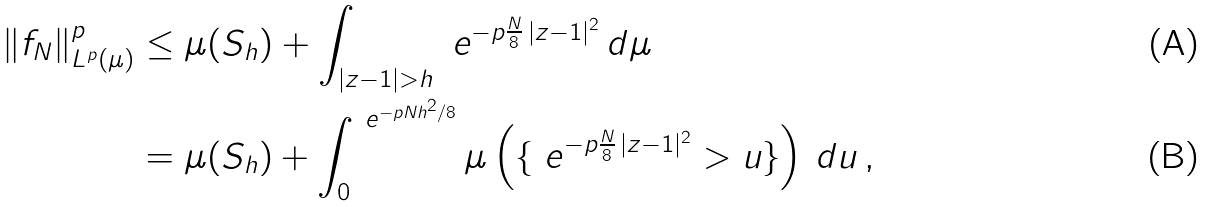Convert formula to latex. <formula><loc_0><loc_0><loc_500><loc_500>\| f _ { N } \| _ { L ^ { p } ( \mu ) } ^ { p } & \leq \mu ( S _ { h } ) + \int _ { | z - 1 | > h } \ e ^ { - p \frac { N } { 8 } \, | z - 1 | ^ { 2 } } \, d \mu \\ & = \mu ( S _ { h } ) + \int _ { 0 } ^ { \ e ^ { - p N h ^ { 2 } / 8 } } \mu \left ( \{ \ e ^ { - p \frac { N } { 8 } \, | z - 1 | ^ { 2 } } > u \} \right ) \, d u \, ,</formula> 